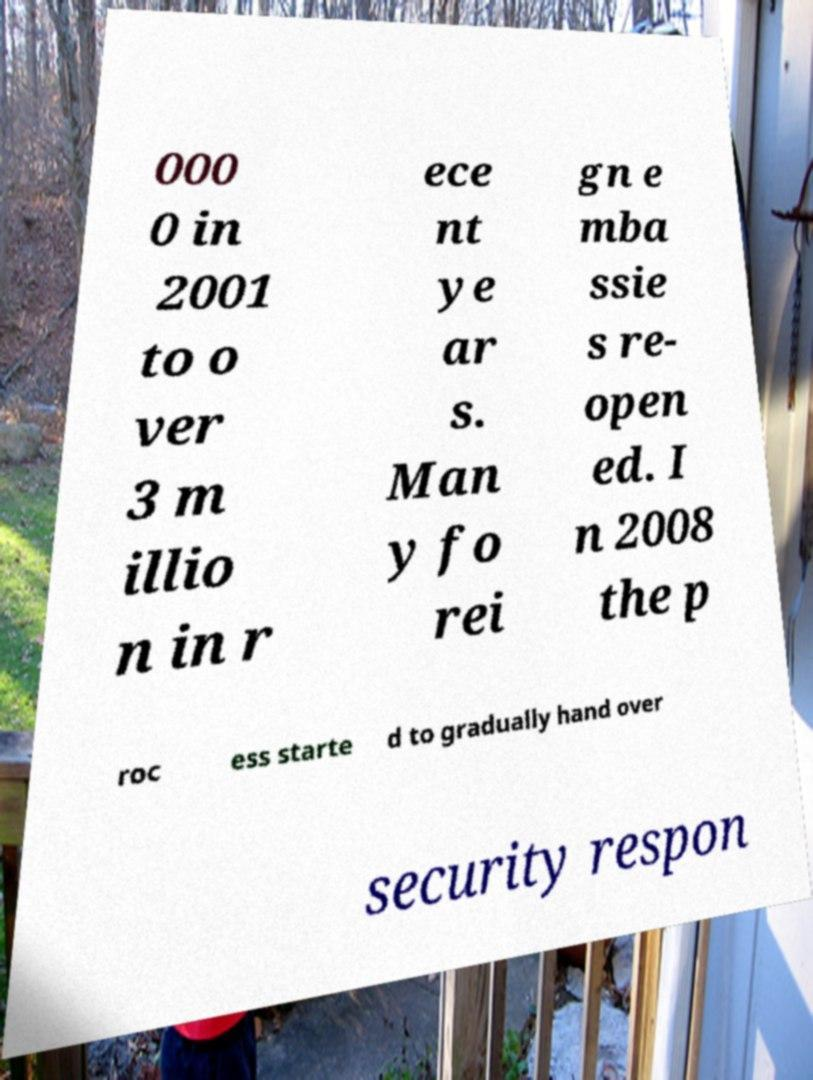There's text embedded in this image that I need extracted. Can you transcribe it verbatim? 000 0 in 2001 to o ver 3 m illio n in r ece nt ye ar s. Man y fo rei gn e mba ssie s re- open ed. I n 2008 the p roc ess starte d to gradually hand over security respon 